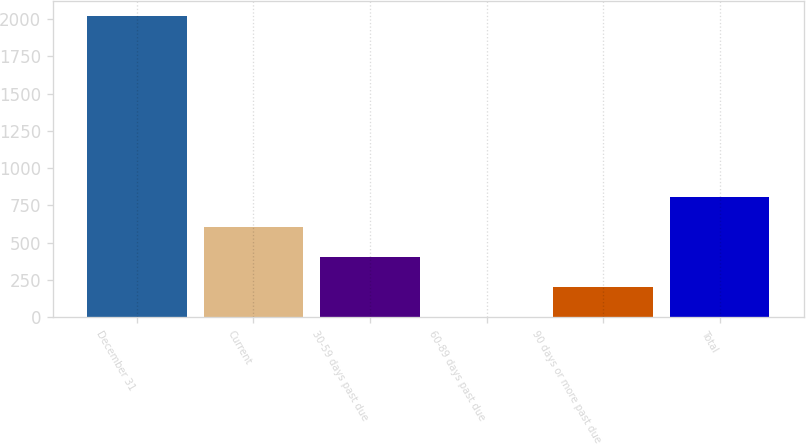Convert chart to OTSL. <chart><loc_0><loc_0><loc_500><loc_500><bar_chart><fcel>December 31<fcel>Current<fcel>30-59 days past due<fcel>60-89 days past due<fcel>90 days or more past due<fcel>Total<nl><fcel>2018<fcel>606.45<fcel>404.8<fcel>1.5<fcel>203.15<fcel>808.1<nl></chart> 